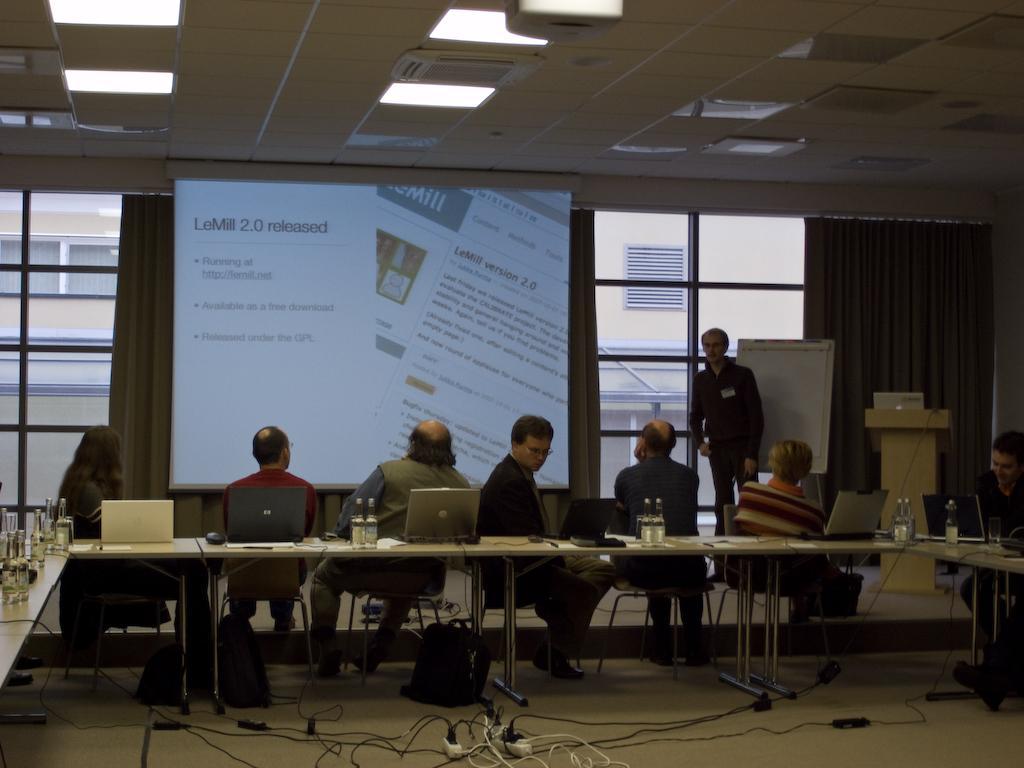In one or two sentences, can you explain what this image depicts? This picture describes about group of people, they are seated on the chairs and a man is standing, in front of them we can find few bottles, laptops and other things on the tables, in the background we can see a projector screen, curtains and lights, and also we can see a building. 